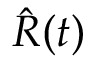Convert formula to latex. <formula><loc_0><loc_0><loc_500><loc_500>\hat { R } ( t )</formula> 